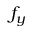Convert formula to latex. <formula><loc_0><loc_0><loc_500><loc_500>f _ { y }</formula> 